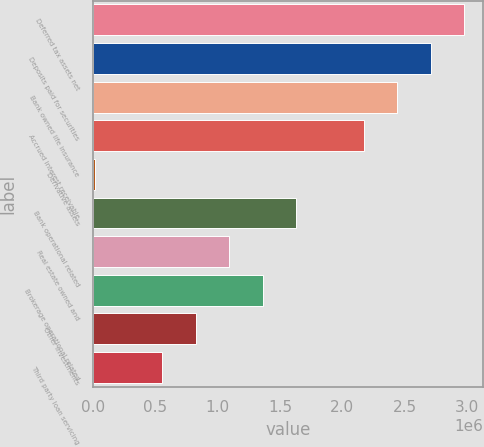Convert chart. <chart><loc_0><loc_0><loc_500><loc_500><bar_chart><fcel>Deferred tax assets net<fcel>Deposits paid for securities<fcel>Bank owned life insurance<fcel>Accrued interest receivable<fcel>Derivative assets<fcel>Bank operational related<fcel>Real estate owned and<fcel>Brokerage operational related<fcel>Other investments<fcel>Third party loan servicing<nl><fcel>2.98052e+06<fcel>2.71092e+06<fcel>2.44132e+06<fcel>2.17171e+06<fcel>14890<fcel>1.63251e+06<fcel>1.0933e+06<fcel>1.36291e+06<fcel>823699<fcel>554096<nl></chart> 